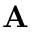Convert formula to latex. <formula><loc_0><loc_0><loc_500><loc_500>A</formula> 